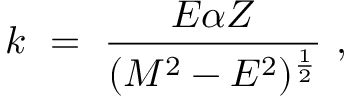Convert formula to latex. <formula><loc_0><loc_0><loc_500><loc_500>k \ = \ { \frac { E \alpha Z } { ( M ^ { 2 } - E ^ { 2 } ) ^ { \frac { 1 } { 2 } } } } \ ,</formula> 